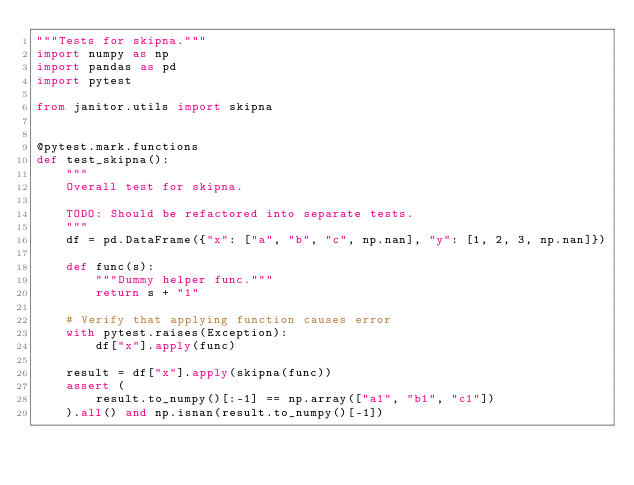<code> <loc_0><loc_0><loc_500><loc_500><_Python_>"""Tests for skipna."""
import numpy as np
import pandas as pd
import pytest

from janitor.utils import skipna


@pytest.mark.functions
def test_skipna():
    """
    Overall test for skipna.

    TODO: Should be refactored into separate tests.
    """
    df = pd.DataFrame({"x": ["a", "b", "c", np.nan], "y": [1, 2, 3, np.nan]})

    def func(s):
        """Dummy helper func."""
        return s + "1"

    # Verify that applying function causes error
    with pytest.raises(Exception):
        df["x"].apply(func)

    result = df["x"].apply(skipna(func))
    assert (
        result.to_numpy()[:-1] == np.array(["a1", "b1", "c1"])
    ).all() and np.isnan(result.to_numpy()[-1])
</code> 